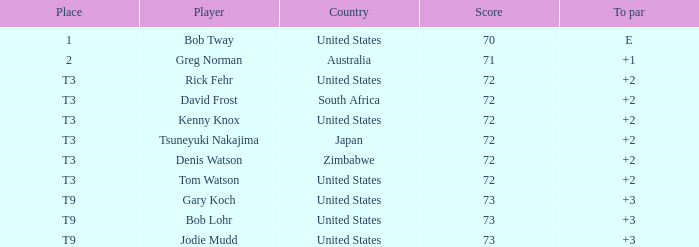What is the top score for tsuneyuki nakajima? 72.0. I'm looking to parse the entire table for insights. Could you assist me with that? {'header': ['Place', 'Player', 'Country', 'Score', 'To par'], 'rows': [['1', 'Bob Tway', 'United States', '70', 'E'], ['2', 'Greg Norman', 'Australia', '71', '+1'], ['T3', 'Rick Fehr', 'United States', '72', '+2'], ['T3', 'David Frost', 'South Africa', '72', '+2'], ['T3', 'Kenny Knox', 'United States', '72', '+2'], ['T3', 'Tsuneyuki Nakajima', 'Japan', '72', '+2'], ['T3', 'Denis Watson', 'Zimbabwe', '72', '+2'], ['T3', 'Tom Watson', 'United States', '72', '+2'], ['T9', 'Gary Koch', 'United States', '73', '+3'], ['T9', 'Bob Lohr', 'United States', '73', '+3'], ['T9', 'Jodie Mudd', 'United States', '73', '+3']]} 